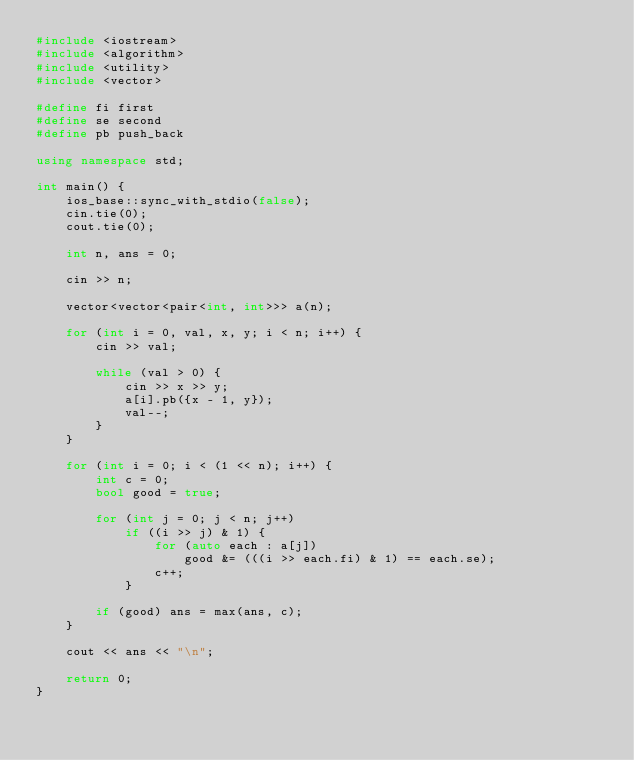<code> <loc_0><loc_0><loc_500><loc_500><_C++_>#include <iostream>
#include <algorithm>
#include <utility>
#include <vector>

#define fi first
#define se second
#define pb push_back

using namespace std;

int main() {
    ios_base::sync_with_stdio(false);
    cin.tie(0);
    cout.tie(0);

    int n, ans = 0;

    cin >> n;

    vector<vector<pair<int, int>>> a(n);

    for (int i = 0, val, x, y; i < n; i++) {
        cin >> val;

        while (val > 0) {
            cin >> x >> y;
            a[i].pb({x - 1, y});
            val--;
        }
    }

    for (int i = 0; i < (1 << n); i++) {
        int c = 0;
        bool good = true;

        for (int j = 0; j < n; j++)
            if ((i >> j) & 1) {
                for (auto each : a[j])
                    good &= (((i >> each.fi) & 1) == each.se);
                c++;
            }

        if (good) ans = max(ans, c);
    }

    cout << ans << "\n";

    return 0;
}
</code> 